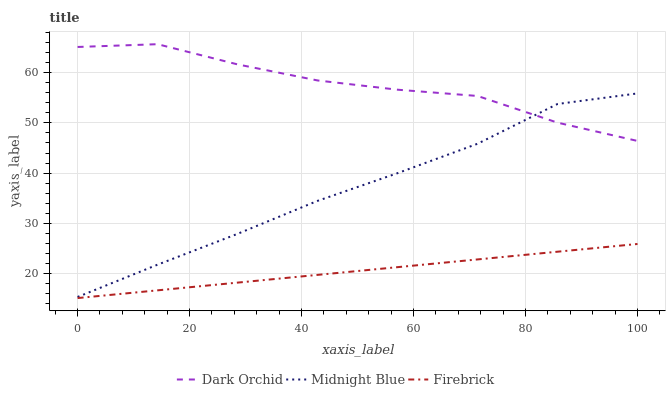Does Firebrick have the minimum area under the curve?
Answer yes or no. Yes. Does Dark Orchid have the maximum area under the curve?
Answer yes or no. Yes. Does Midnight Blue have the minimum area under the curve?
Answer yes or no. No. Does Midnight Blue have the maximum area under the curve?
Answer yes or no. No. Is Firebrick the smoothest?
Answer yes or no. Yes. Is Dark Orchid the roughest?
Answer yes or no. Yes. Is Midnight Blue the smoothest?
Answer yes or no. No. Is Midnight Blue the roughest?
Answer yes or no. No. Does Firebrick have the lowest value?
Answer yes or no. Yes. Does Midnight Blue have the lowest value?
Answer yes or no. No. Does Dark Orchid have the highest value?
Answer yes or no. Yes. Does Midnight Blue have the highest value?
Answer yes or no. No. Is Firebrick less than Dark Orchid?
Answer yes or no. Yes. Is Midnight Blue greater than Firebrick?
Answer yes or no. Yes. Does Dark Orchid intersect Midnight Blue?
Answer yes or no. Yes. Is Dark Orchid less than Midnight Blue?
Answer yes or no. No. Is Dark Orchid greater than Midnight Blue?
Answer yes or no. No. Does Firebrick intersect Dark Orchid?
Answer yes or no. No. 